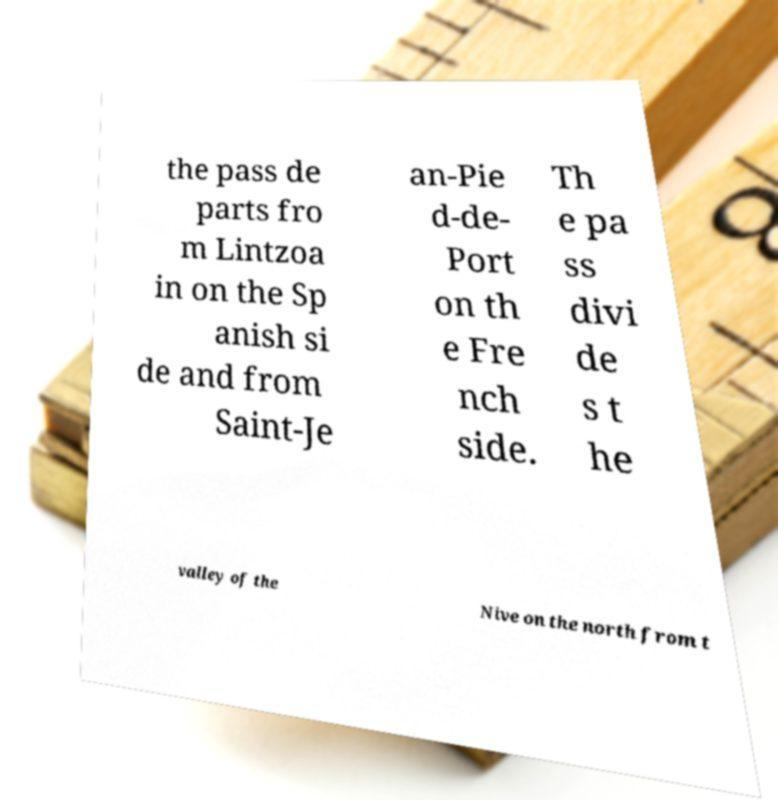Please identify and transcribe the text found in this image. the pass de parts fro m Lintzoa in on the Sp anish si de and from Saint-Je an-Pie d-de- Port on th e Fre nch side. Th e pa ss divi de s t he valley of the Nive on the north from t 